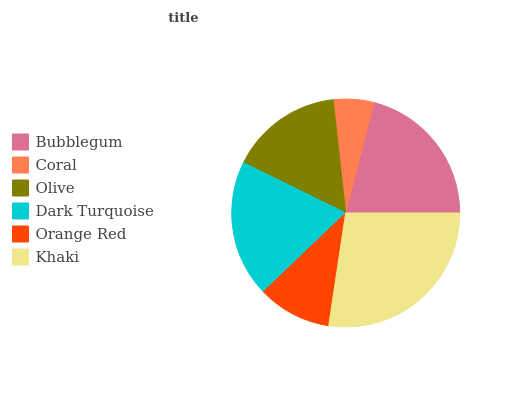Is Coral the minimum?
Answer yes or no. Yes. Is Khaki the maximum?
Answer yes or no. Yes. Is Olive the minimum?
Answer yes or no. No. Is Olive the maximum?
Answer yes or no. No. Is Olive greater than Coral?
Answer yes or no. Yes. Is Coral less than Olive?
Answer yes or no. Yes. Is Coral greater than Olive?
Answer yes or no. No. Is Olive less than Coral?
Answer yes or no. No. Is Dark Turquoise the high median?
Answer yes or no. Yes. Is Olive the low median?
Answer yes or no. Yes. Is Orange Red the high median?
Answer yes or no. No. Is Bubblegum the low median?
Answer yes or no. No. 